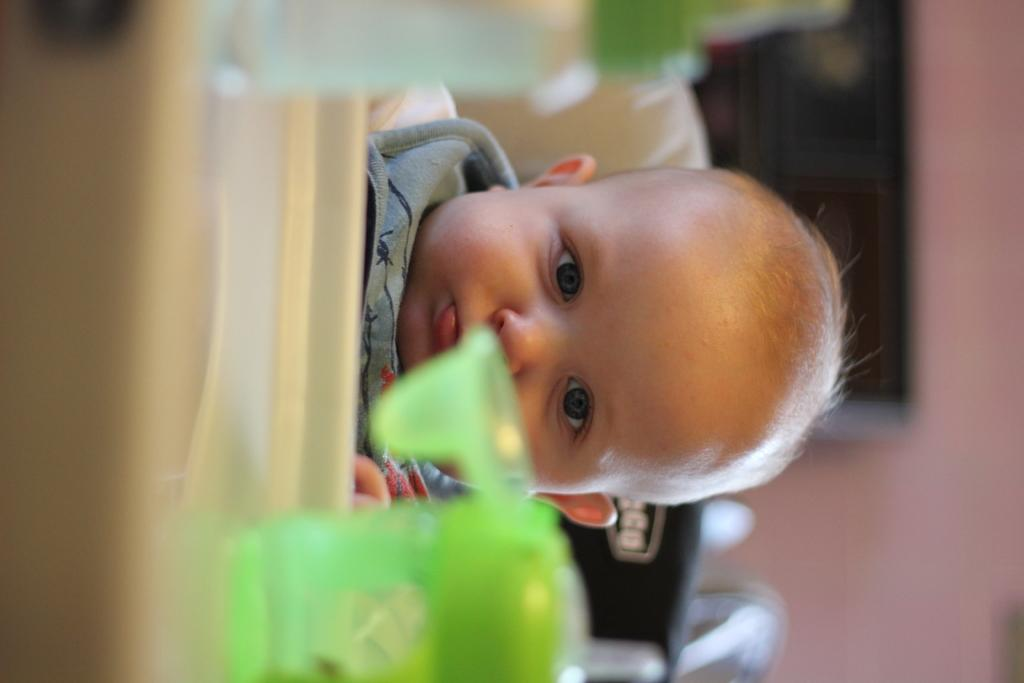What is the main subject of the image? The main subject of the image is a child. What object is present in the image alongside the child? There is a bottle in the image. What type of root can be seen growing from the child's head in the image? There is no root growing from the child's head in the image. 